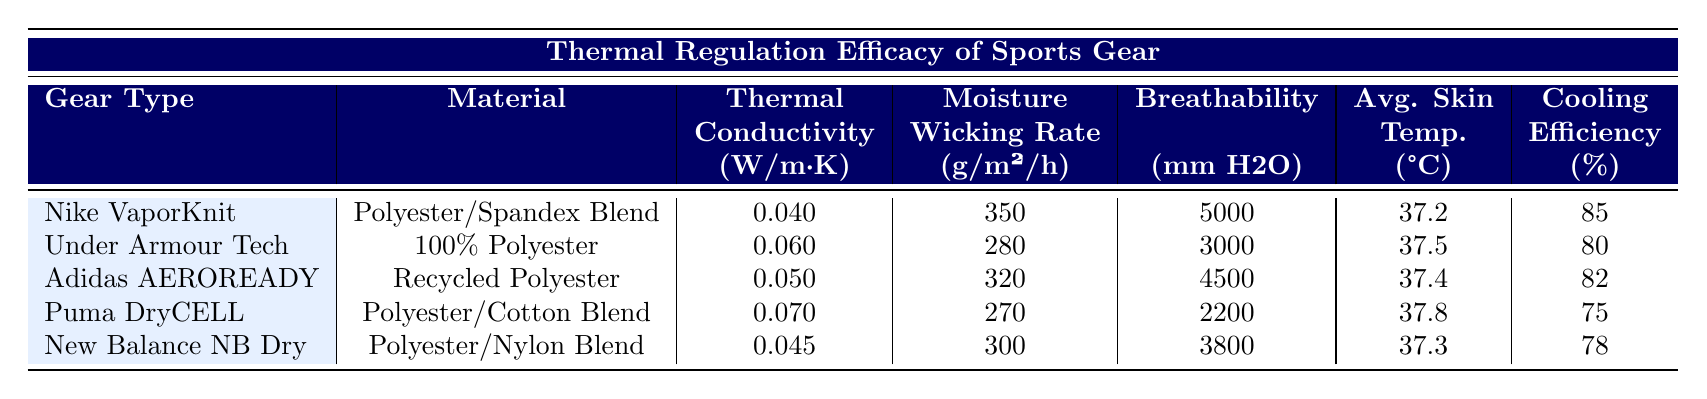What is the thermal conductivity of Nike VaporKnit? The table shows that the thermal conductivity for Nike VaporKnit is listed under the corresponding column with the value of 0.040 (W/m·K).
Answer: 0.040 Which gear type has the highest breathability? By comparing the breathability values in the table, Nike VaporKnit has a breathability of 5000 mm H2O, which is the highest among all listed gear types.
Answer: Nike VaporKnit Is the cooling efficiency of Adidas AEROREADY greater than 80%? The cooling efficiency of Adidas AEROREADY is listed as 82%, which is indeed greater than 80%.
Answer: Yes What is the average skin temperature during activity for Puma DryCELL? The table indicates the average skin temperature during activity for Puma DryCELL is 37.8°C, which can be directly retrieved from the corresponding row.
Answer: 37.8°C Calculate the average moisture wicking rate among all gear types. To find the average moisture wicking rate, sum all the values: (350 + 280 + 320 + 270 + 300) = 1520 g/m²/h. Divide by the number of gear types (5): 1520/5 = 304 g/m²/h.
Answer: 304 Which gear has the lowest cooling efficiency? Checking the cooling efficiency column, Puma DryCELL with a cooling efficiency of 75% is the lowest value compared to other gear types listed.
Answer: Puma DryCELL Is the moisture wicking rate of New Balance NB Dry higher than that of Under Armour Tech? The moisture wicking rate for New Balance NB Dry is 300 g/m²/h, while Under Armour Tech is at 280 g/m²/h. Since 300 is greater than 280, the statement is true.
Answer: Yes What is the difference in average skin temperature between Nike VaporKnit and Adidas AEROREADY? The average skin temperature for Nike VaporKnit is 37.2°C, and for Adidas AEROREADY it is 37.4°C. The difference is calculated as 37.4 - 37.2 = 0.2°C.
Answer: 0.2°C Which material is used in the Nike VaporKnit gear? Referring to the material column for Nike VaporKnit, it is indicated as a Polyester/Spandex Blend.
Answer: Polyester/Spandex Blend 